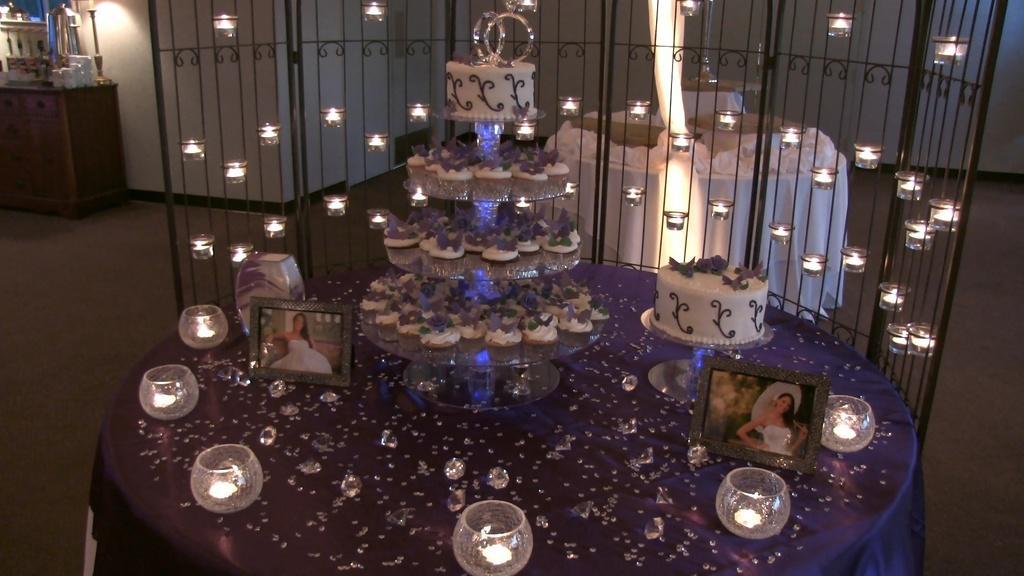Can you describe this image briefly? In this picture, it seems like candles, cakes and frames on a table in the foreground, there is a table, desk and other objects in the background. 